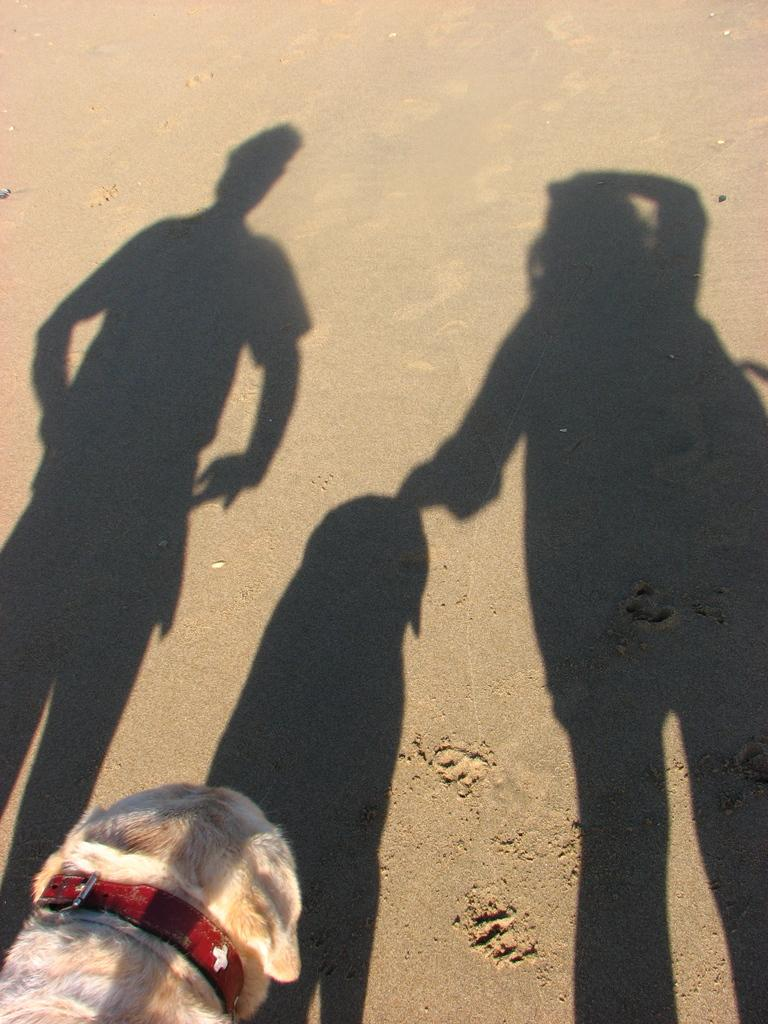How many shadows can be seen on the sand ground in the image? There are three shadows on the sand ground in the image. What animal is present in the image? There is a dog in the image. What distinguishing feature does the dog have? The dog has a red color belt around its neck. What type of system is being used by the dog to play baseball in the image? There is no baseball or system present in the image; it only features a dog with a red color belt around its neck and three shadows on the sand ground. Can you point out the map that the dog is using to navigate in the image? There is no map present in the image; it only features a dog with a red color belt around its neck and three shadows on the sand ground. 